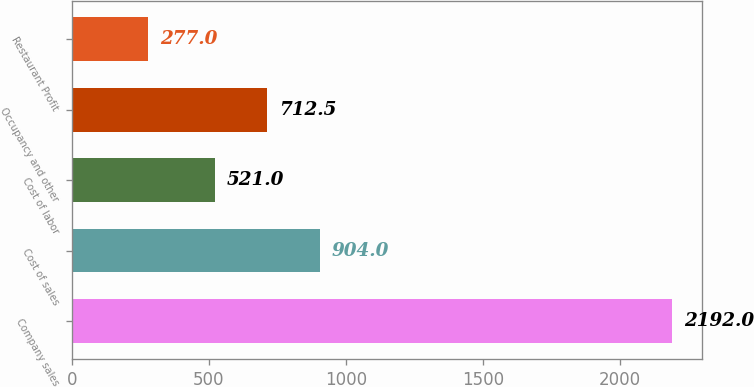Convert chart to OTSL. <chart><loc_0><loc_0><loc_500><loc_500><bar_chart><fcel>Company sales<fcel>Cost of sales<fcel>Cost of labor<fcel>Occupancy and other<fcel>Restaurant Profit<nl><fcel>2192<fcel>904<fcel>521<fcel>712.5<fcel>277<nl></chart> 